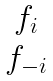Convert formula to latex. <formula><loc_0><loc_0><loc_500><loc_500>\begin{matrix} f _ { i } \\ f _ { - i } \end{matrix}</formula> 